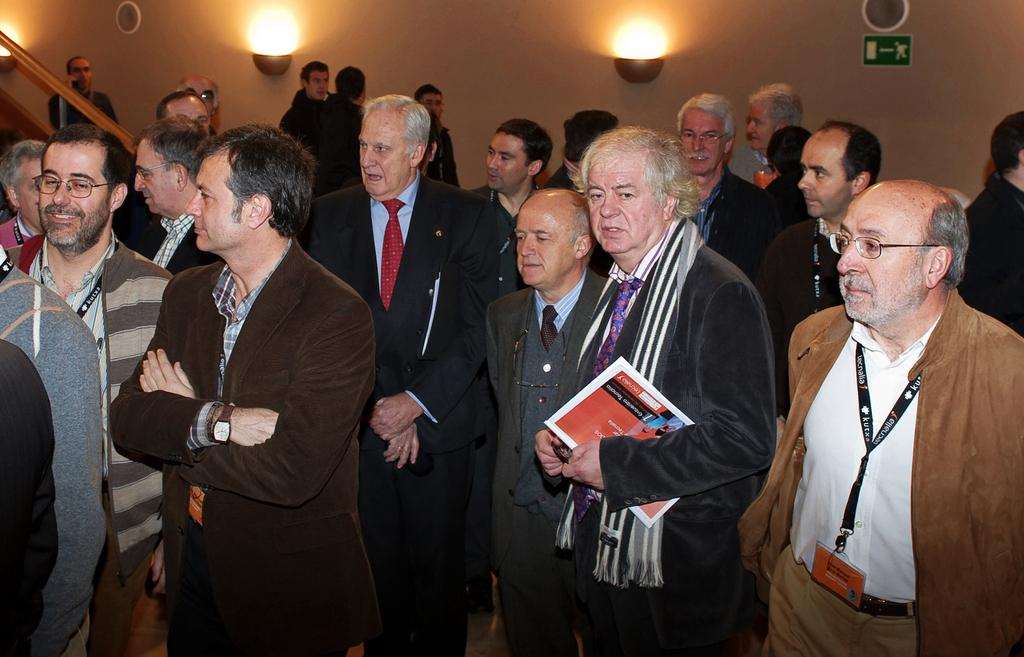What type of clothing are the men in the image wearing? The men in the image are wearing blazers. What is one man holding in the image? One man is holding a book. What can be seen in the background of the image? There is a wall in the background of the image. How many lights are on the wall in the background? There are two lights on the wall in the background. What type of list is the boy holding in the image? There is no boy present in the image, and therefore no list can be observed. What type of bear can be seen interacting with the men in the image? There is no bear present in the image; only the men and the book are visible. 